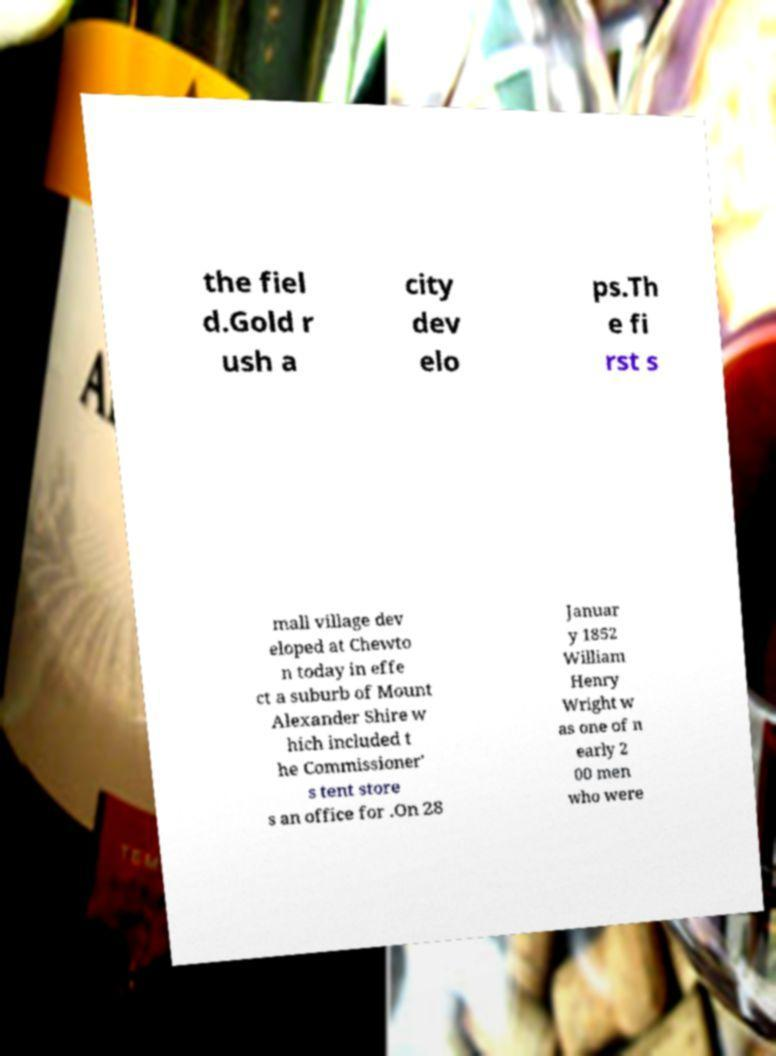There's text embedded in this image that I need extracted. Can you transcribe it verbatim? the fiel d.Gold r ush a city dev elo ps.Th e fi rst s mall village dev eloped at Chewto n today in effe ct a suburb of Mount Alexander Shire w hich included t he Commissioner' s tent store s an office for .On 28 Januar y 1852 William Henry Wright w as one of n early 2 00 men who were 